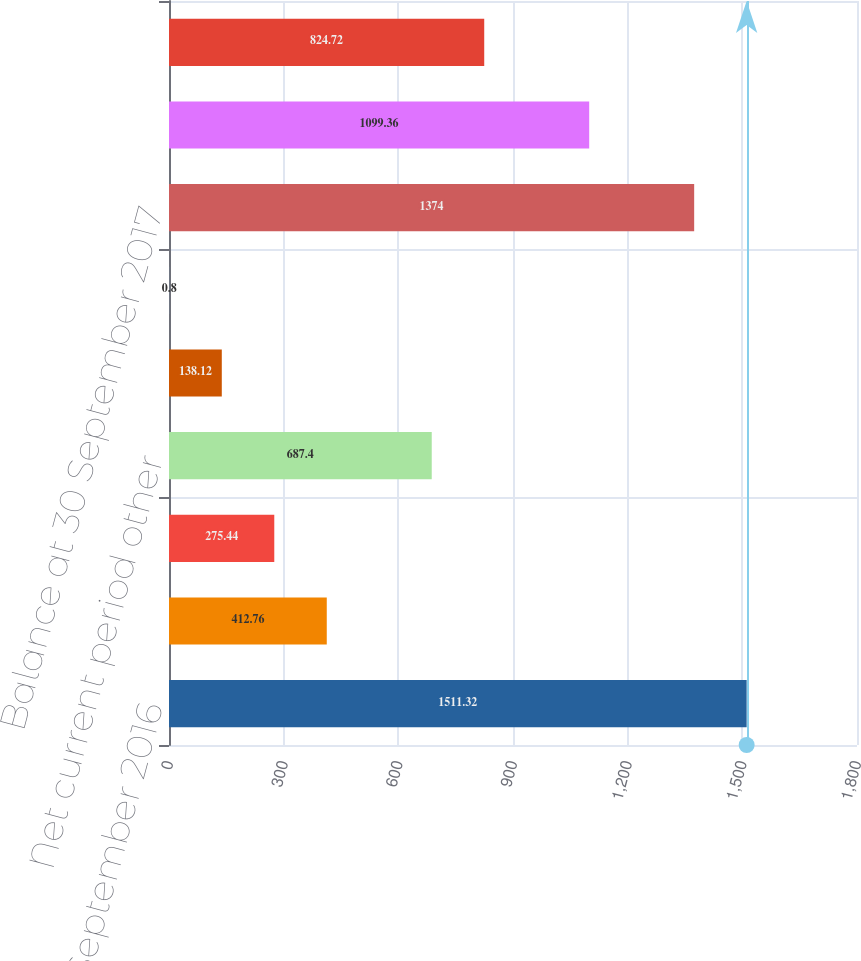Convert chart to OTSL. <chart><loc_0><loc_0><loc_500><loc_500><bar_chart><fcel>Balance at 30 September 2016<fcel>Other comprehensive income<fcel>Amounts reclassified from AOCL<fcel>Net current period other<fcel>Spin-off of Versum<fcel>Amount attributable to<fcel>Balance at 30 September 2017<fcel>Balance at 30 September 2018<fcel>Other comprehensive loss<nl><fcel>1511.32<fcel>412.76<fcel>275.44<fcel>687.4<fcel>138.12<fcel>0.8<fcel>1374<fcel>1099.36<fcel>824.72<nl></chart> 